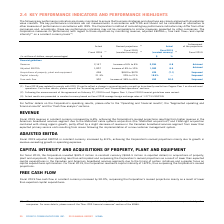According to Cogeco's financial document, How does the corporation measure its performance? Based on the financial document, the answer is The Corporation measures its performance, with regard to these objectives by monitoring revenue, adjusted EBITDA(1), free cash flow(1) and capital intensity(1) on a constant currency basis(1).. Also, When were the fiscal 2019 financial guidelines revised? According to the financial document, February 27, 2019. The relevant text states: "2) Following the announcement of the agreement on February 27, 2019 to sell Cogeco Peer 1, fiscal 2019 financial guidelines were revised...." Also, What was the status of achievement of projections in 2019 for revenue? According to the financial document, Achieved. The relevant text states: "Revenue 2,147 Increase of 6% to 8% 2,294 6.8 Achieved..." Also, can you calculate: What was the increase / (decrease) in the revenue from 2018 to 2019? Based on the calculation: 2,294 - 2,147, the result is 147 (in millions). This is based on the information: "Revenue 2,147 Increase of 6% to 8% 2,294 6.8 Achieved Revenue 2,147 Increase of 6% to 8% 2,294 6.8 Achieved..." The key data points involved are: 2,147, 2,294. Also, can you calculate: What was the average Adjusted EBITDA between 2018 to 2019? To answer this question, I need to perform calculations using the financial data. The calculation is: (1,007 + 1,092) / 2, which equals 1049.5 (in millions). This is based on the information: "Adjusted EBITDA 1,007 Increase of 8% to 10% 1,092 8.5 Achieved Adjusted EBITDA 1,007 Increase of 8% to 10% 1,092 8.5 Achieved..." The key data points involved are: 1,007, 1,092. Also, can you calculate: What was the increase / (decrease) in Free Cash flow from 2018 to 2019? Based on the calculation: 453 - 302, the result is 151 (in millions). This is based on the information: "Free cash flow 302 Increase of 38% to 45% 453 50.0 Surpassed Free cash flow 302 Increase of 38% to 45% 453 50.0 Surpassed..." The key data points involved are: 302, 453. 